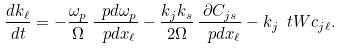<formula> <loc_0><loc_0><loc_500><loc_500>\frac { d k _ { \ell } } { d t } = - \frac { \omega _ { p } } { \Omega } \, \frac { \ p d \omega _ { p } } { \ p d x _ { \ell } } - \frac { k _ { j } k _ { s } } { 2 \Omega } \, \frac { \partial C _ { j s } } { \ p d x _ { \ell } } - k _ { j } \ t W c _ { j \ell } .</formula> 